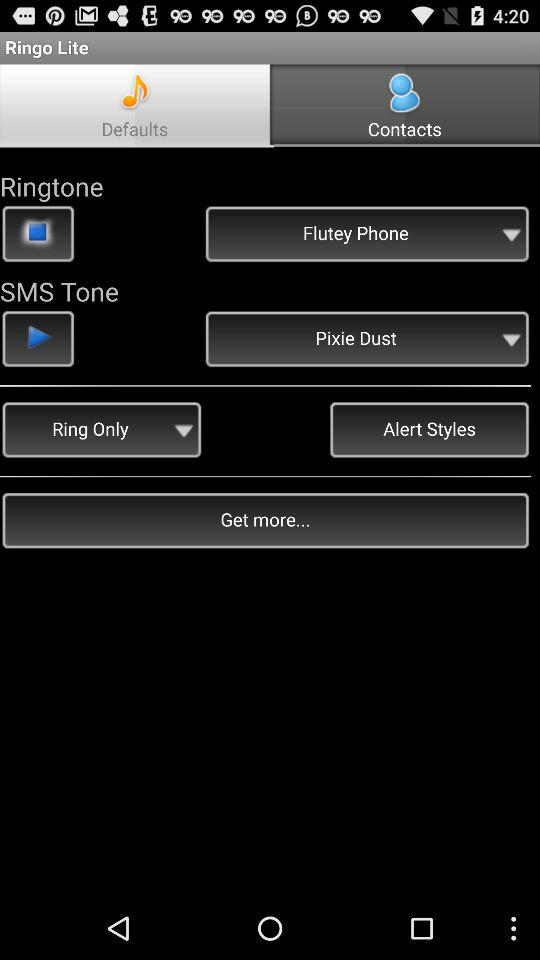Which ringtone is selected? The selected ringtone is "Flutey Phone". 